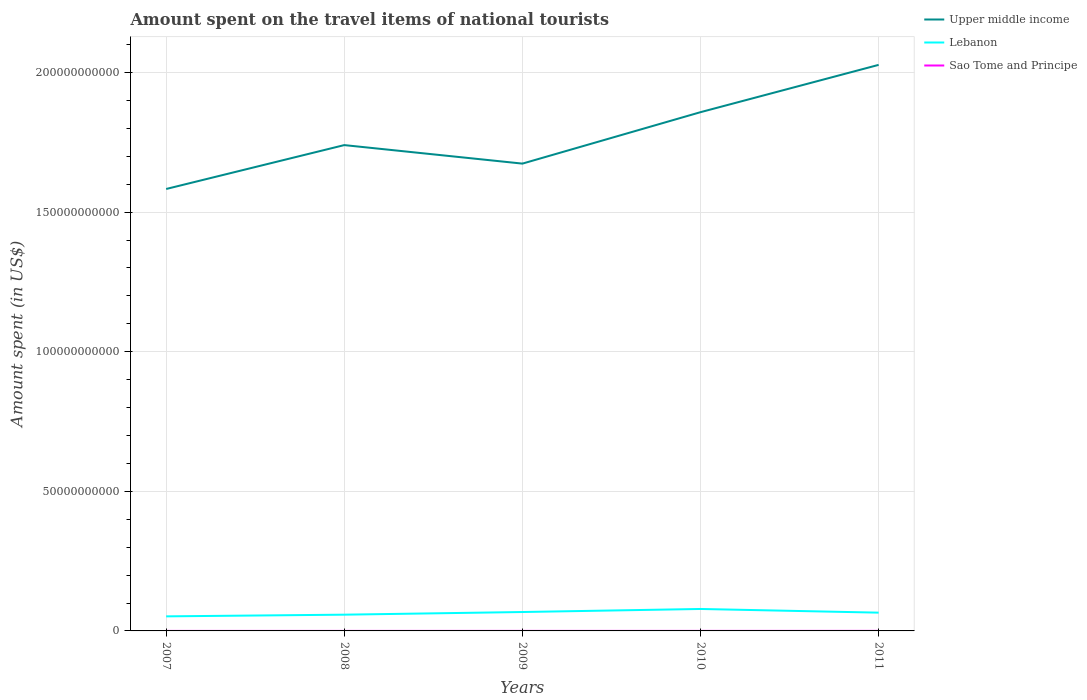How many different coloured lines are there?
Provide a short and direct response. 3. Does the line corresponding to Upper middle income intersect with the line corresponding to Sao Tome and Principe?
Your response must be concise. No. Is the number of lines equal to the number of legend labels?
Your answer should be compact. Yes. Across all years, what is the maximum amount spent on the travel items of national tourists in Upper middle income?
Your response must be concise. 1.58e+11. What is the total amount spent on the travel items of national tourists in Upper middle income in the graph?
Make the answer very short. -9.09e+09. What is the difference between the highest and the second highest amount spent on the travel items of national tourists in Upper middle income?
Make the answer very short. 4.45e+1. What is the difference between the highest and the lowest amount spent on the travel items of national tourists in Lebanon?
Make the answer very short. 3. How many lines are there?
Give a very brief answer. 3. Are the values on the major ticks of Y-axis written in scientific E-notation?
Make the answer very short. No. How are the legend labels stacked?
Offer a very short reply. Vertical. What is the title of the graph?
Your answer should be very brief. Amount spent on the travel items of national tourists. What is the label or title of the X-axis?
Offer a terse response. Years. What is the label or title of the Y-axis?
Your answer should be very brief. Amount spent (in US$). What is the Amount spent (in US$) in Upper middle income in 2007?
Ensure brevity in your answer.  1.58e+11. What is the Amount spent (in US$) in Lebanon in 2007?
Keep it short and to the point. 5.22e+09. What is the Amount spent (in US$) in Upper middle income in 2008?
Provide a succinct answer. 1.74e+11. What is the Amount spent (in US$) of Lebanon in 2008?
Offer a very short reply. 5.82e+09. What is the Amount spent (in US$) of Sao Tome and Principe in 2008?
Your response must be concise. 7.70e+06. What is the Amount spent (in US$) in Upper middle income in 2009?
Your answer should be compact. 1.67e+11. What is the Amount spent (in US$) in Lebanon in 2009?
Your response must be concise. 6.77e+09. What is the Amount spent (in US$) of Sao Tome and Principe in 2009?
Ensure brevity in your answer.  8.30e+06. What is the Amount spent (in US$) of Upper middle income in 2010?
Your response must be concise. 1.86e+11. What is the Amount spent (in US$) of Lebanon in 2010?
Your answer should be very brief. 7.86e+09. What is the Amount spent (in US$) in Sao Tome and Principe in 2010?
Give a very brief answer. 1.11e+07. What is the Amount spent (in US$) in Upper middle income in 2011?
Make the answer very short. 2.03e+11. What is the Amount spent (in US$) in Lebanon in 2011?
Your answer should be compact. 6.54e+09. What is the Amount spent (in US$) in Sao Tome and Principe in 2011?
Keep it short and to the point. 1.59e+07. Across all years, what is the maximum Amount spent (in US$) of Upper middle income?
Provide a short and direct response. 2.03e+11. Across all years, what is the maximum Amount spent (in US$) of Lebanon?
Keep it short and to the point. 7.86e+09. Across all years, what is the maximum Amount spent (in US$) in Sao Tome and Principe?
Give a very brief answer. 1.59e+07. Across all years, what is the minimum Amount spent (in US$) in Upper middle income?
Offer a terse response. 1.58e+11. Across all years, what is the minimum Amount spent (in US$) in Lebanon?
Your answer should be very brief. 5.22e+09. What is the total Amount spent (in US$) in Upper middle income in the graph?
Your answer should be very brief. 8.88e+11. What is the total Amount spent (in US$) in Lebanon in the graph?
Offer a very short reply. 3.22e+1. What is the total Amount spent (in US$) in Sao Tome and Principe in the graph?
Offer a terse response. 4.80e+07. What is the difference between the Amount spent (in US$) in Upper middle income in 2007 and that in 2008?
Keep it short and to the point. -1.57e+1. What is the difference between the Amount spent (in US$) in Lebanon in 2007 and that in 2008?
Provide a succinct answer. -6.03e+08. What is the difference between the Amount spent (in US$) of Sao Tome and Principe in 2007 and that in 2008?
Offer a very short reply. -2.70e+06. What is the difference between the Amount spent (in US$) of Upper middle income in 2007 and that in 2009?
Provide a short and direct response. -9.09e+09. What is the difference between the Amount spent (in US$) of Lebanon in 2007 and that in 2009?
Make the answer very short. -1.56e+09. What is the difference between the Amount spent (in US$) in Sao Tome and Principe in 2007 and that in 2009?
Make the answer very short. -3.30e+06. What is the difference between the Amount spent (in US$) in Upper middle income in 2007 and that in 2010?
Your response must be concise. -2.75e+1. What is the difference between the Amount spent (in US$) in Lebanon in 2007 and that in 2010?
Offer a terse response. -2.64e+09. What is the difference between the Amount spent (in US$) in Sao Tome and Principe in 2007 and that in 2010?
Your response must be concise. -6.10e+06. What is the difference between the Amount spent (in US$) of Upper middle income in 2007 and that in 2011?
Ensure brevity in your answer.  -4.45e+1. What is the difference between the Amount spent (in US$) in Lebanon in 2007 and that in 2011?
Your answer should be very brief. -1.33e+09. What is the difference between the Amount spent (in US$) of Sao Tome and Principe in 2007 and that in 2011?
Provide a short and direct response. -1.09e+07. What is the difference between the Amount spent (in US$) of Upper middle income in 2008 and that in 2009?
Your answer should be compact. 6.63e+09. What is the difference between the Amount spent (in US$) of Lebanon in 2008 and that in 2009?
Give a very brief answer. -9.55e+08. What is the difference between the Amount spent (in US$) of Sao Tome and Principe in 2008 and that in 2009?
Keep it short and to the point. -6.00e+05. What is the difference between the Amount spent (in US$) of Upper middle income in 2008 and that in 2010?
Keep it short and to the point. -1.18e+1. What is the difference between the Amount spent (in US$) in Lebanon in 2008 and that in 2010?
Keep it short and to the point. -2.04e+09. What is the difference between the Amount spent (in US$) in Sao Tome and Principe in 2008 and that in 2010?
Offer a very short reply. -3.40e+06. What is the difference between the Amount spent (in US$) in Upper middle income in 2008 and that in 2011?
Keep it short and to the point. -2.87e+1. What is the difference between the Amount spent (in US$) of Lebanon in 2008 and that in 2011?
Make the answer very short. -7.26e+08. What is the difference between the Amount spent (in US$) of Sao Tome and Principe in 2008 and that in 2011?
Your answer should be compact. -8.20e+06. What is the difference between the Amount spent (in US$) of Upper middle income in 2009 and that in 2010?
Your answer should be very brief. -1.84e+1. What is the difference between the Amount spent (in US$) of Lebanon in 2009 and that in 2010?
Provide a short and direct response. -1.09e+09. What is the difference between the Amount spent (in US$) of Sao Tome and Principe in 2009 and that in 2010?
Ensure brevity in your answer.  -2.80e+06. What is the difference between the Amount spent (in US$) in Upper middle income in 2009 and that in 2011?
Keep it short and to the point. -3.54e+1. What is the difference between the Amount spent (in US$) of Lebanon in 2009 and that in 2011?
Your answer should be compact. 2.29e+08. What is the difference between the Amount spent (in US$) of Sao Tome and Principe in 2009 and that in 2011?
Your answer should be very brief. -7.60e+06. What is the difference between the Amount spent (in US$) in Upper middle income in 2010 and that in 2011?
Give a very brief answer. -1.69e+1. What is the difference between the Amount spent (in US$) of Lebanon in 2010 and that in 2011?
Your response must be concise. 1.32e+09. What is the difference between the Amount spent (in US$) of Sao Tome and Principe in 2010 and that in 2011?
Offer a very short reply. -4.80e+06. What is the difference between the Amount spent (in US$) in Upper middle income in 2007 and the Amount spent (in US$) in Lebanon in 2008?
Give a very brief answer. 1.52e+11. What is the difference between the Amount spent (in US$) of Upper middle income in 2007 and the Amount spent (in US$) of Sao Tome and Principe in 2008?
Make the answer very short. 1.58e+11. What is the difference between the Amount spent (in US$) of Lebanon in 2007 and the Amount spent (in US$) of Sao Tome and Principe in 2008?
Provide a short and direct response. 5.21e+09. What is the difference between the Amount spent (in US$) in Upper middle income in 2007 and the Amount spent (in US$) in Lebanon in 2009?
Keep it short and to the point. 1.52e+11. What is the difference between the Amount spent (in US$) of Upper middle income in 2007 and the Amount spent (in US$) of Sao Tome and Principe in 2009?
Offer a terse response. 1.58e+11. What is the difference between the Amount spent (in US$) of Lebanon in 2007 and the Amount spent (in US$) of Sao Tome and Principe in 2009?
Make the answer very short. 5.21e+09. What is the difference between the Amount spent (in US$) of Upper middle income in 2007 and the Amount spent (in US$) of Lebanon in 2010?
Keep it short and to the point. 1.50e+11. What is the difference between the Amount spent (in US$) of Upper middle income in 2007 and the Amount spent (in US$) of Sao Tome and Principe in 2010?
Offer a terse response. 1.58e+11. What is the difference between the Amount spent (in US$) of Lebanon in 2007 and the Amount spent (in US$) of Sao Tome and Principe in 2010?
Your answer should be very brief. 5.20e+09. What is the difference between the Amount spent (in US$) of Upper middle income in 2007 and the Amount spent (in US$) of Lebanon in 2011?
Your answer should be very brief. 1.52e+11. What is the difference between the Amount spent (in US$) of Upper middle income in 2007 and the Amount spent (in US$) of Sao Tome and Principe in 2011?
Your answer should be very brief. 1.58e+11. What is the difference between the Amount spent (in US$) of Lebanon in 2007 and the Amount spent (in US$) of Sao Tome and Principe in 2011?
Offer a very short reply. 5.20e+09. What is the difference between the Amount spent (in US$) in Upper middle income in 2008 and the Amount spent (in US$) in Lebanon in 2009?
Offer a terse response. 1.67e+11. What is the difference between the Amount spent (in US$) in Upper middle income in 2008 and the Amount spent (in US$) in Sao Tome and Principe in 2009?
Your answer should be very brief. 1.74e+11. What is the difference between the Amount spent (in US$) of Lebanon in 2008 and the Amount spent (in US$) of Sao Tome and Principe in 2009?
Ensure brevity in your answer.  5.81e+09. What is the difference between the Amount spent (in US$) of Upper middle income in 2008 and the Amount spent (in US$) of Lebanon in 2010?
Provide a succinct answer. 1.66e+11. What is the difference between the Amount spent (in US$) of Upper middle income in 2008 and the Amount spent (in US$) of Sao Tome and Principe in 2010?
Offer a very short reply. 1.74e+11. What is the difference between the Amount spent (in US$) in Lebanon in 2008 and the Amount spent (in US$) in Sao Tome and Principe in 2010?
Your answer should be compact. 5.81e+09. What is the difference between the Amount spent (in US$) of Upper middle income in 2008 and the Amount spent (in US$) of Lebanon in 2011?
Make the answer very short. 1.67e+11. What is the difference between the Amount spent (in US$) in Upper middle income in 2008 and the Amount spent (in US$) in Sao Tome and Principe in 2011?
Ensure brevity in your answer.  1.74e+11. What is the difference between the Amount spent (in US$) of Lebanon in 2008 and the Amount spent (in US$) of Sao Tome and Principe in 2011?
Offer a very short reply. 5.80e+09. What is the difference between the Amount spent (in US$) of Upper middle income in 2009 and the Amount spent (in US$) of Lebanon in 2010?
Give a very brief answer. 1.60e+11. What is the difference between the Amount spent (in US$) of Upper middle income in 2009 and the Amount spent (in US$) of Sao Tome and Principe in 2010?
Offer a very short reply. 1.67e+11. What is the difference between the Amount spent (in US$) of Lebanon in 2009 and the Amount spent (in US$) of Sao Tome and Principe in 2010?
Offer a very short reply. 6.76e+09. What is the difference between the Amount spent (in US$) of Upper middle income in 2009 and the Amount spent (in US$) of Lebanon in 2011?
Provide a succinct answer. 1.61e+11. What is the difference between the Amount spent (in US$) of Upper middle income in 2009 and the Amount spent (in US$) of Sao Tome and Principe in 2011?
Give a very brief answer. 1.67e+11. What is the difference between the Amount spent (in US$) in Lebanon in 2009 and the Amount spent (in US$) in Sao Tome and Principe in 2011?
Your answer should be very brief. 6.76e+09. What is the difference between the Amount spent (in US$) in Upper middle income in 2010 and the Amount spent (in US$) in Lebanon in 2011?
Your answer should be compact. 1.79e+11. What is the difference between the Amount spent (in US$) in Upper middle income in 2010 and the Amount spent (in US$) in Sao Tome and Principe in 2011?
Provide a short and direct response. 1.86e+11. What is the difference between the Amount spent (in US$) in Lebanon in 2010 and the Amount spent (in US$) in Sao Tome and Principe in 2011?
Your response must be concise. 7.85e+09. What is the average Amount spent (in US$) of Upper middle income per year?
Offer a terse response. 1.78e+11. What is the average Amount spent (in US$) of Lebanon per year?
Keep it short and to the point. 6.44e+09. What is the average Amount spent (in US$) in Sao Tome and Principe per year?
Give a very brief answer. 9.60e+06. In the year 2007, what is the difference between the Amount spent (in US$) of Upper middle income and Amount spent (in US$) of Lebanon?
Offer a terse response. 1.53e+11. In the year 2007, what is the difference between the Amount spent (in US$) in Upper middle income and Amount spent (in US$) in Sao Tome and Principe?
Offer a terse response. 1.58e+11. In the year 2007, what is the difference between the Amount spent (in US$) of Lebanon and Amount spent (in US$) of Sao Tome and Principe?
Ensure brevity in your answer.  5.21e+09. In the year 2008, what is the difference between the Amount spent (in US$) of Upper middle income and Amount spent (in US$) of Lebanon?
Provide a succinct answer. 1.68e+11. In the year 2008, what is the difference between the Amount spent (in US$) of Upper middle income and Amount spent (in US$) of Sao Tome and Principe?
Keep it short and to the point. 1.74e+11. In the year 2008, what is the difference between the Amount spent (in US$) in Lebanon and Amount spent (in US$) in Sao Tome and Principe?
Ensure brevity in your answer.  5.81e+09. In the year 2009, what is the difference between the Amount spent (in US$) of Upper middle income and Amount spent (in US$) of Lebanon?
Offer a terse response. 1.61e+11. In the year 2009, what is the difference between the Amount spent (in US$) in Upper middle income and Amount spent (in US$) in Sao Tome and Principe?
Give a very brief answer. 1.67e+11. In the year 2009, what is the difference between the Amount spent (in US$) in Lebanon and Amount spent (in US$) in Sao Tome and Principe?
Your answer should be very brief. 6.77e+09. In the year 2010, what is the difference between the Amount spent (in US$) in Upper middle income and Amount spent (in US$) in Lebanon?
Your answer should be very brief. 1.78e+11. In the year 2010, what is the difference between the Amount spent (in US$) in Upper middle income and Amount spent (in US$) in Sao Tome and Principe?
Provide a short and direct response. 1.86e+11. In the year 2010, what is the difference between the Amount spent (in US$) in Lebanon and Amount spent (in US$) in Sao Tome and Principe?
Ensure brevity in your answer.  7.85e+09. In the year 2011, what is the difference between the Amount spent (in US$) of Upper middle income and Amount spent (in US$) of Lebanon?
Make the answer very short. 1.96e+11. In the year 2011, what is the difference between the Amount spent (in US$) of Upper middle income and Amount spent (in US$) of Sao Tome and Principe?
Make the answer very short. 2.03e+11. In the year 2011, what is the difference between the Amount spent (in US$) of Lebanon and Amount spent (in US$) of Sao Tome and Principe?
Give a very brief answer. 6.53e+09. What is the ratio of the Amount spent (in US$) in Upper middle income in 2007 to that in 2008?
Offer a very short reply. 0.91. What is the ratio of the Amount spent (in US$) in Lebanon in 2007 to that in 2008?
Your answer should be very brief. 0.9. What is the ratio of the Amount spent (in US$) in Sao Tome and Principe in 2007 to that in 2008?
Provide a succinct answer. 0.65. What is the ratio of the Amount spent (in US$) in Upper middle income in 2007 to that in 2009?
Give a very brief answer. 0.95. What is the ratio of the Amount spent (in US$) of Lebanon in 2007 to that in 2009?
Keep it short and to the point. 0.77. What is the ratio of the Amount spent (in US$) in Sao Tome and Principe in 2007 to that in 2009?
Offer a terse response. 0.6. What is the ratio of the Amount spent (in US$) in Upper middle income in 2007 to that in 2010?
Your response must be concise. 0.85. What is the ratio of the Amount spent (in US$) of Lebanon in 2007 to that in 2010?
Your answer should be very brief. 0.66. What is the ratio of the Amount spent (in US$) in Sao Tome and Principe in 2007 to that in 2010?
Provide a short and direct response. 0.45. What is the ratio of the Amount spent (in US$) in Upper middle income in 2007 to that in 2011?
Provide a succinct answer. 0.78. What is the ratio of the Amount spent (in US$) of Lebanon in 2007 to that in 2011?
Make the answer very short. 0.8. What is the ratio of the Amount spent (in US$) in Sao Tome and Principe in 2007 to that in 2011?
Keep it short and to the point. 0.31. What is the ratio of the Amount spent (in US$) of Upper middle income in 2008 to that in 2009?
Give a very brief answer. 1.04. What is the ratio of the Amount spent (in US$) of Lebanon in 2008 to that in 2009?
Your answer should be compact. 0.86. What is the ratio of the Amount spent (in US$) of Sao Tome and Principe in 2008 to that in 2009?
Keep it short and to the point. 0.93. What is the ratio of the Amount spent (in US$) of Upper middle income in 2008 to that in 2010?
Your answer should be very brief. 0.94. What is the ratio of the Amount spent (in US$) of Lebanon in 2008 to that in 2010?
Your answer should be very brief. 0.74. What is the ratio of the Amount spent (in US$) of Sao Tome and Principe in 2008 to that in 2010?
Make the answer very short. 0.69. What is the ratio of the Amount spent (in US$) of Upper middle income in 2008 to that in 2011?
Your answer should be compact. 0.86. What is the ratio of the Amount spent (in US$) of Lebanon in 2008 to that in 2011?
Make the answer very short. 0.89. What is the ratio of the Amount spent (in US$) in Sao Tome and Principe in 2008 to that in 2011?
Your answer should be compact. 0.48. What is the ratio of the Amount spent (in US$) of Upper middle income in 2009 to that in 2010?
Give a very brief answer. 0.9. What is the ratio of the Amount spent (in US$) in Lebanon in 2009 to that in 2010?
Provide a short and direct response. 0.86. What is the ratio of the Amount spent (in US$) in Sao Tome and Principe in 2009 to that in 2010?
Offer a terse response. 0.75. What is the ratio of the Amount spent (in US$) of Upper middle income in 2009 to that in 2011?
Offer a terse response. 0.83. What is the ratio of the Amount spent (in US$) in Lebanon in 2009 to that in 2011?
Keep it short and to the point. 1.03. What is the ratio of the Amount spent (in US$) in Sao Tome and Principe in 2009 to that in 2011?
Offer a terse response. 0.52. What is the ratio of the Amount spent (in US$) of Upper middle income in 2010 to that in 2011?
Offer a terse response. 0.92. What is the ratio of the Amount spent (in US$) in Lebanon in 2010 to that in 2011?
Make the answer very short. 1.2. What is the ratio of the Amount spent (in US$) of Sao Tome and Principe in 2010 to that in 2011?
Your answer should be very brief. 0.7. What is the difference between the highest and the second highest Amount spent (in US$) in Upper middle income?
Offer a terse response. 1.69e+1. What is the difference between the highest and the second highest Amount spent (in US$) in Lebanon?
Provide a succinct answer. 1.09e+09. What is the difference between the highest and the second highest Amount spent (in US$) of Sao Tome and Principe?
Offer a very short reply. 4.80e+06. What is the difference between the highest and the lowest Amount spent (in US$) of Upper middle income?
Keep it short and to the point. 4.45e+1. What is the difference between the highest and the lowest Amount spent (in US$) of Lebanon?
Give a very brief answer. 2.64e+09. What is the difference between the highest and the lowest Amount spent (in US$) of Sao Tome and Principe?
Keep it short and to the point. 1.09e+07. 